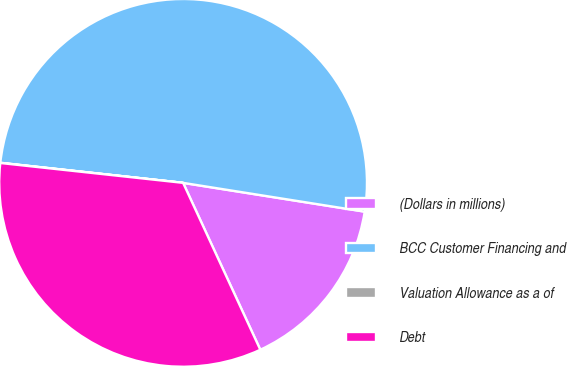<chart> <loc_0><loc_0><loc_500><loc_500><pie_chart><fcel>(Dollars in millions)<fcel>BCC Customer Financing and<fcel>Valuation Allowance as a of<fcel>Debt<nl><fcel>15.6%<fcel>50.76%<fcel>0.02%<fcel>33.62%<nl></chart> 